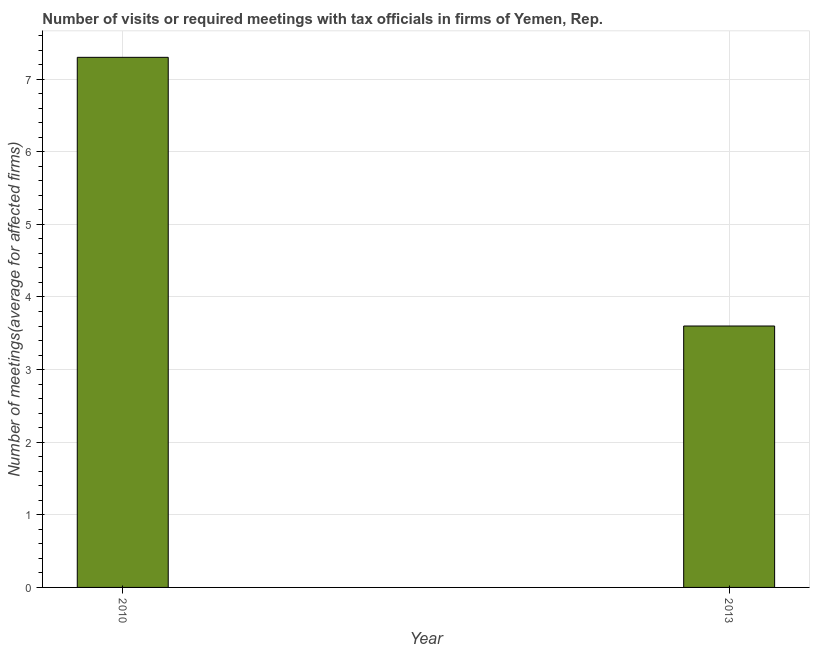Does the graph contain any zero values?
Provide a short and direct response. No. Does the graph contain grids?
Keep it short and to the point. Yes. What is the title of the graph?
Your response must be concise. Number of visits or required meetings with tax officials in firms of Yemen, Rep. What is the label or title of the Y-axis?
Give a very brief answer. Number of meetings(average for affected firms). What is the sum of the number of required meetings with tax officials?
Ensure brevity in your answer.  10.9. What is the difference between the number of required meetings with tax officials in 2010 and 2013?
Your answer should be compact. 3.7. What is the average number of required meetings with tax officials per year?
Keep it short and to the point. 5.45. What is the median number of required meetings with tax officials?
Your answer should be compact. 5.45. What is the ratio of the number of required meetings with tax officials in 2010 to that in 2013?
Offer a terse response. 2.03. Are all the bars in the graph horizontal?
Keep it short and to the point. No. What is the Number of meetings(average for affected firms) of 2013?
Keep it short and to the point. 3.6. What is the ratio of the Number of meetings(average for affected firms) in 2010 to that in 2013?
Your response must be concise. 2.03. 